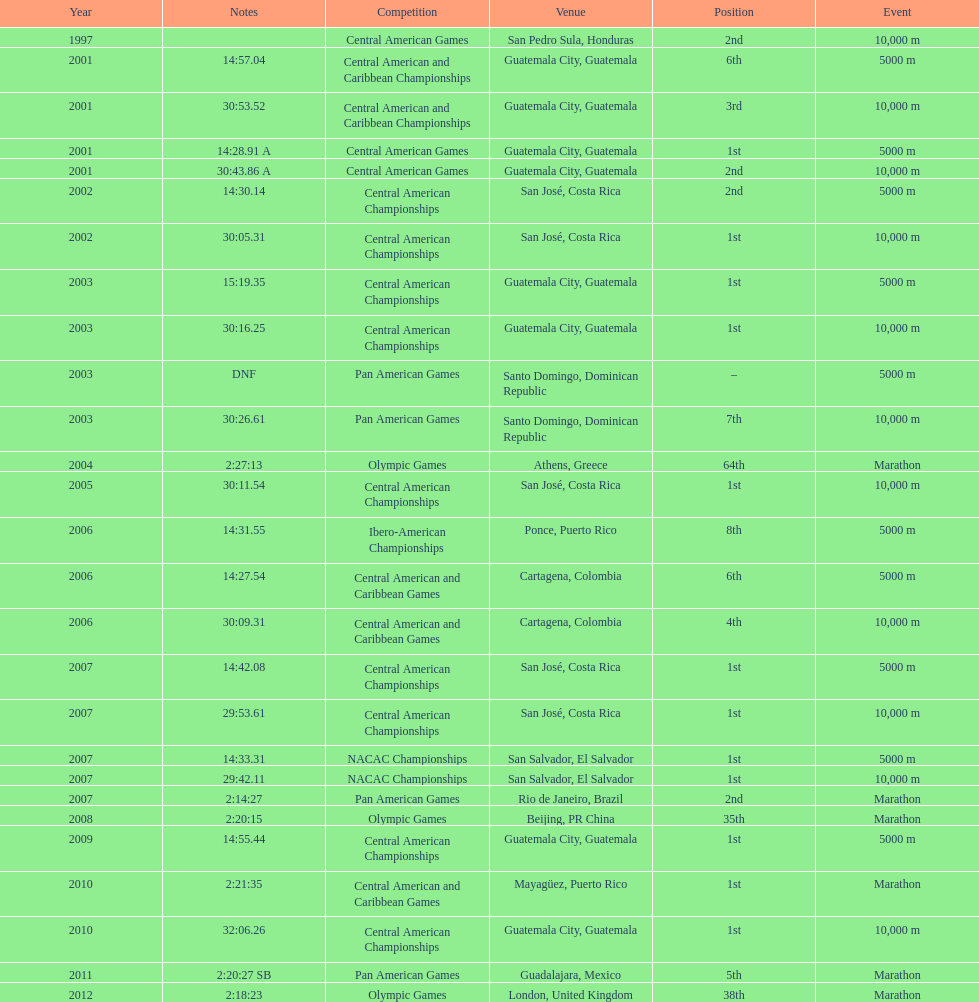Which event is listed more between the 10,000m and the 5000m? 10,000 m. 